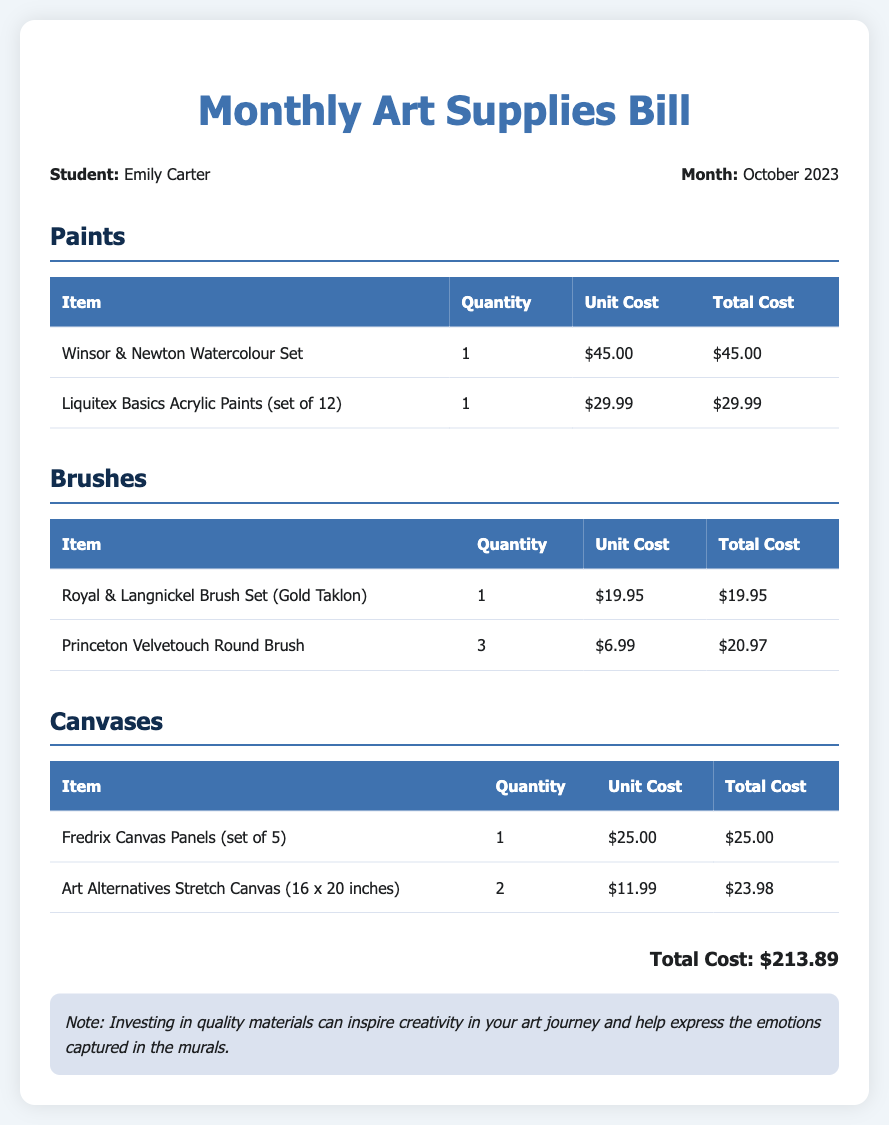What is the name of the student? The document identifies the student as Emily Carter.
Answer: Emily Carter How much did the Winsor & Newton Watercolour Set cost? This item is listed with a unit cost of $45.00.
Answer: $45.00 What month does this bill cover? The bill clearly states the month as October 2023.
Answer: October 2023 How many Princeton Velvetouch Round Brushes were purchased? The document shows a quantity of 3 for this item.
Answer: 3 What is the total cost of the art supplies? The summary at the end indicates the total cost as $213.89.
Answer: $213.89 Which category has the least total cost? By calculating the totals from each section, the brushes category has a total cost of $40.92, which is the least.
Answer: Brushes How many units of Art Alternatives Stretch Canvas were purchased? The document indicates that 2 units were purchased.
Answer: 2 What note is included about the quality of materials? The note emphasizes investing in quality materials to inspire creativity.
Answer: Investing in quality materials can inspire creativity in your art journey 